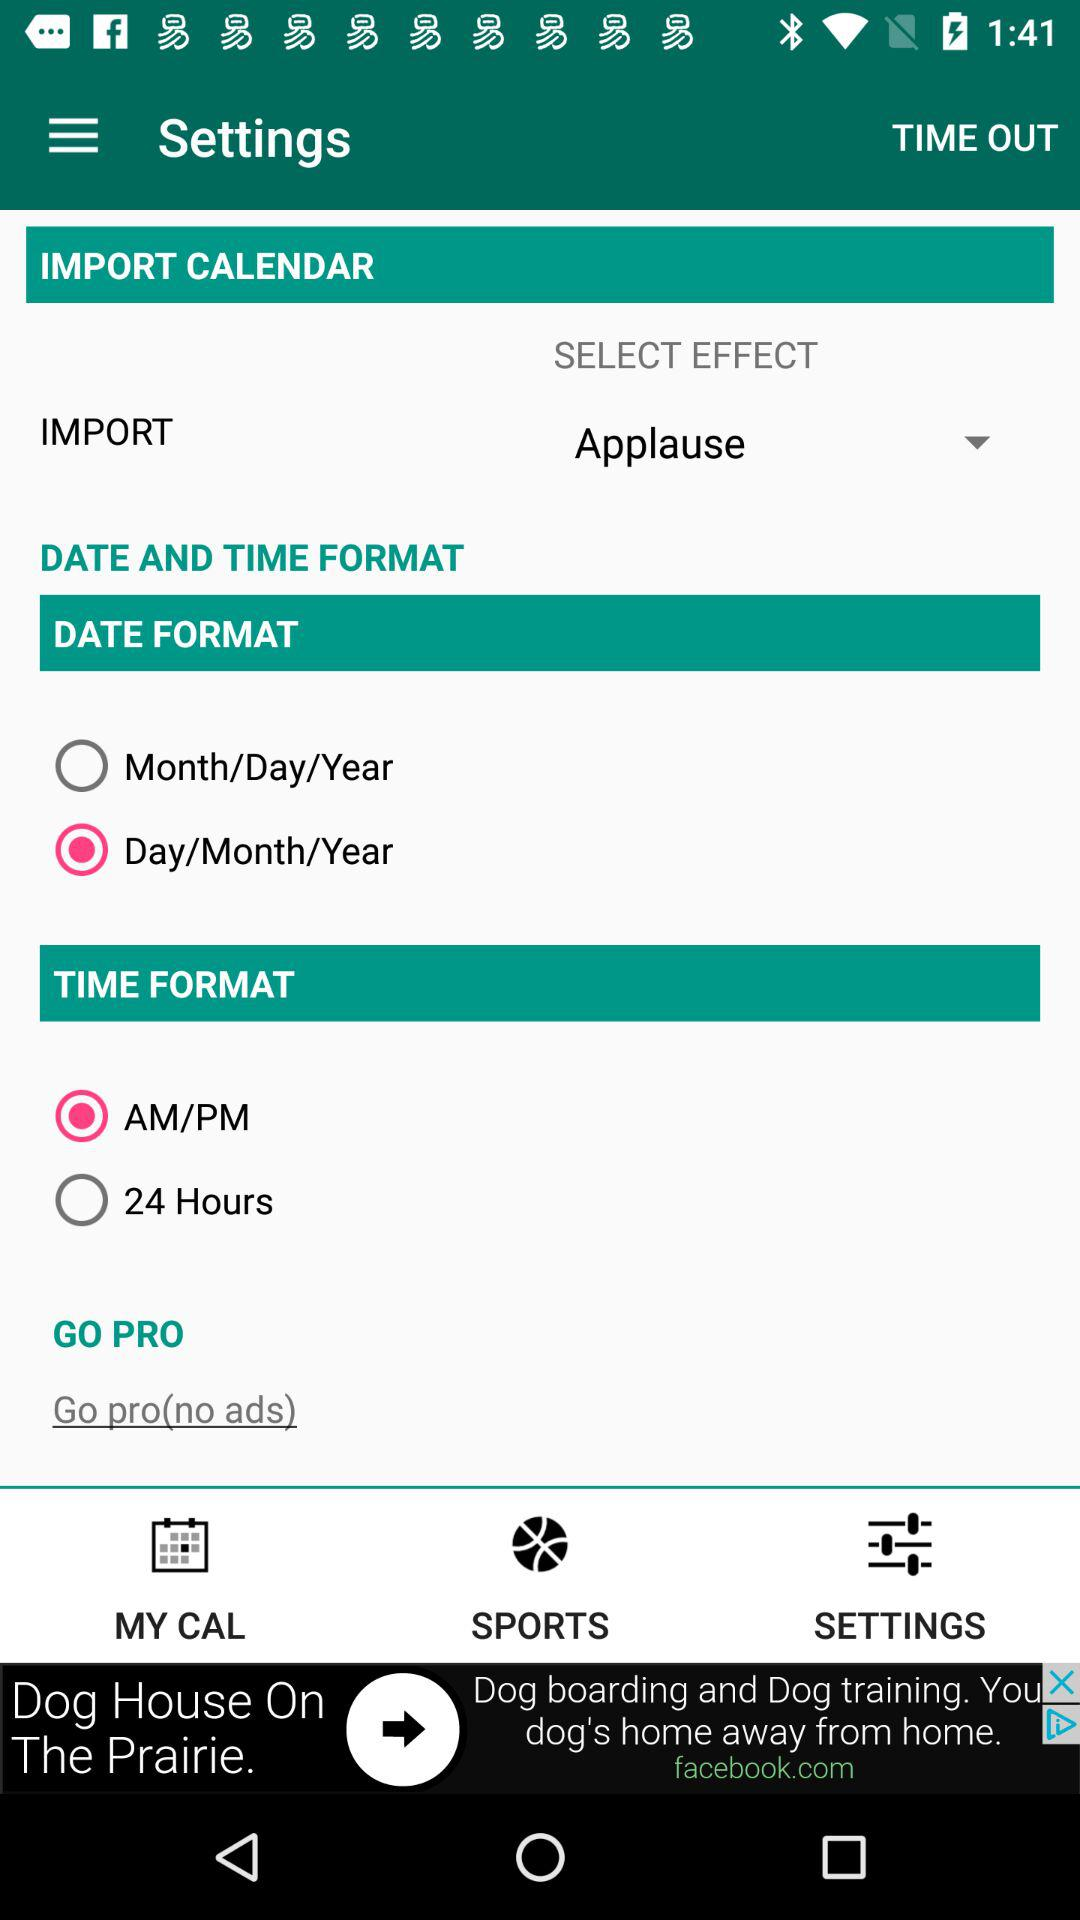What is the selected effect for the calendar? The selected effect is "Applause". 